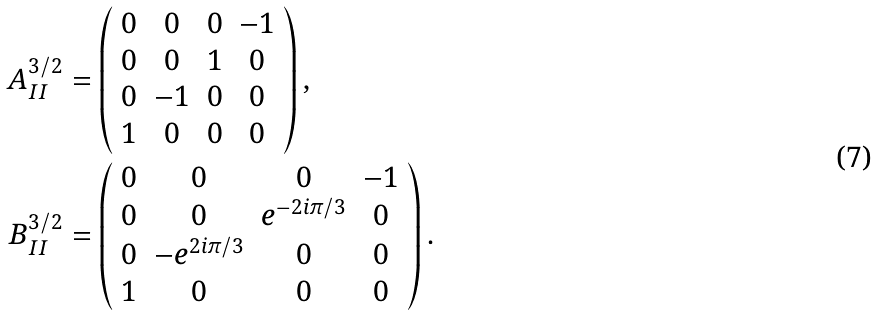Convert formula to latex. <formula><loc_0><loc_0><loc_500><loc_500>A _ { I I } ^ { 3 / 2 } & = \left ( \begin{array} { c c c c } 0 & 0 & 0 & - 1 \\ 0 & 0 & 1 & 0 \\ 0 & - 1 & 0 & 0 \\ 1 & 0 & 0 & 0 \end{array} \right ) , \\ B _ { I I } ^ { 3 / 2 } & = \left ( \begin{array} { c c c c } 0 & 0 & 0 & - 1 \\ 0 & 0 & e ^ { - 2 i \pi / 3 } & 0 \\ 0 & - e ^ { 2 i \pi / 3 } & 0 & 0 \\ 1 & 0 & 0 & 0 \end{array} \right ) .</formula> 